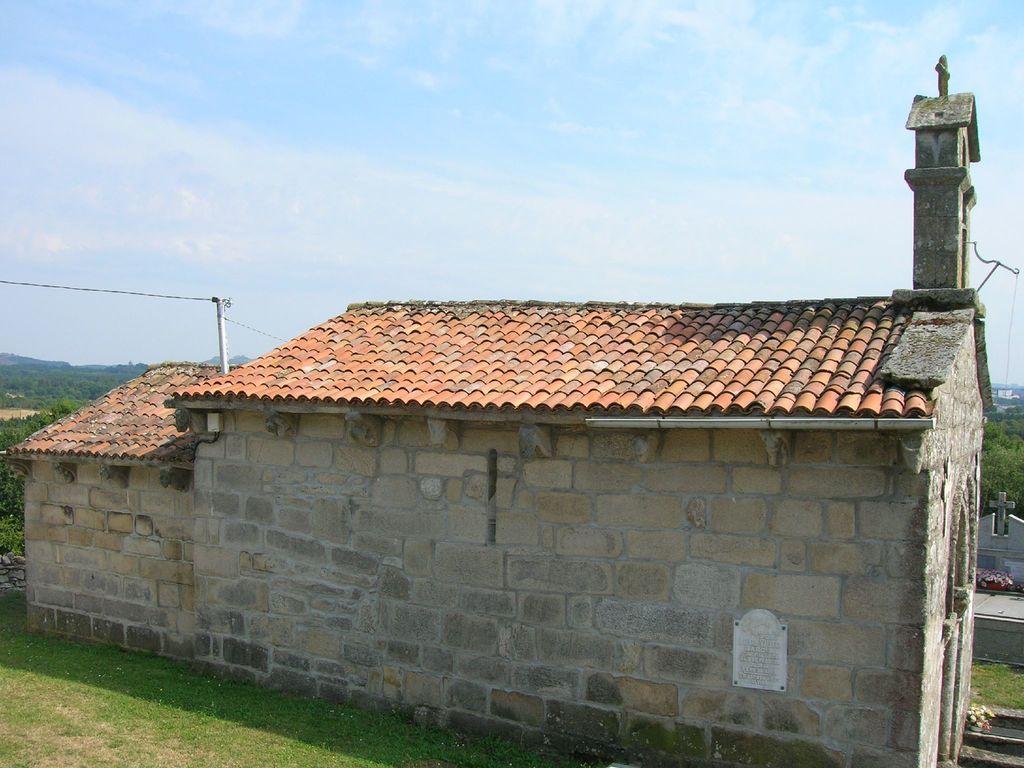Please provide a concise description of this image. In this image we can see a house. At the bottom of the image, we can see the grass. In the background, we can see greenery. At the top of the image, we can see the sky with clouds. 